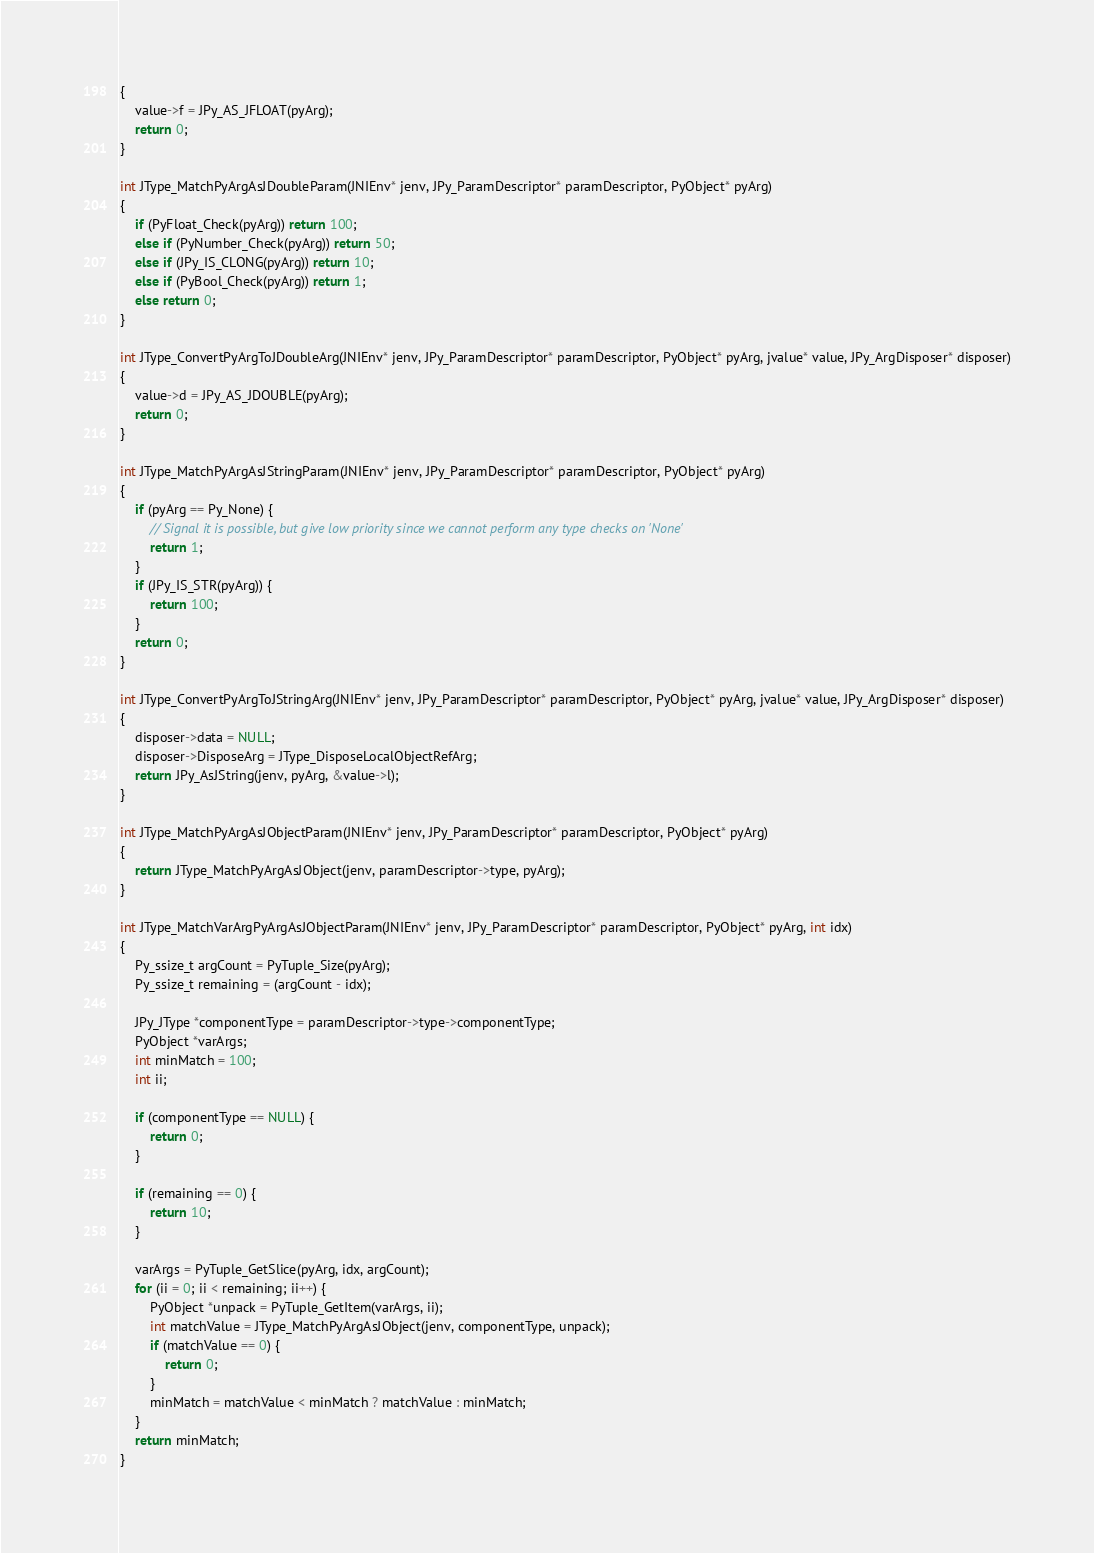Convert code to text. <code><loc_0><loc_0><loc_500><loc_500><_C_>{
    value->f = JPy_AS_JFLOAT(pyArg);
    return 0;
}

int JType_MatchPyArgAsJDoubleParam(JNIEnv* jenv, JPy_ParamDescriptor* paramDescriptor, PyObject* pyArg)
{
    if (PyFloat_Check(pyArg)) return 100;
    else if (PyNumber_Check(pyArg)) return 50;
    else if (JPy_IS_CLONG(pyArg)) return 10;
    else if (PyBool_Check(pyArg)) return 1;
    else return 0;
}

int JType_ConvertPyArgToJDoubleArg(JNIEnv* jenv, JPy_ParamDescriptor* paramDescriptor, PyObject* pyArg, jvalue* value, JPy_ArgDisposer* disposer)
{
    value->d = JPy_AS_JDOUBLE(pyArg);
    return 0;
}

int JType_MatchPyArgAsJStringParam(JNIEnv* jenv, JPy_ParamDescriptor* paramDescriptor, PyObject* pyArg)
{
    if (pyArg == Py_None) {
        // Signal it is possible, but give low priority since we cannot perform any type checks on 'None'
        return 1;
    }
    if (JPy_IS_STR(pyArg)) {
        return 100;
    }
    return 0;
}

int JType_ConvertPyArgToJStringArg(JNIEnv* jenv, JPy_ParamDescriptor* paramDescriptor, PyObject* pyArg, jvalue* value, JPy_ArgDisposer* disposer)
{
    disposer->data = NULL;
    disposer->DisposeArg = JType_DisposeLocalObjectRefArg;
    return JPy_AsJString(jenv, pyArg, &value->l);
}

int JType_MatchPyArgAsJObjectParam(JNIEnv* jenv, JPy_ParamDescriptor* paramDescriptor, PyObject* pyArg)
{
    return JType_MatchPyArgAsJObject(jenv, paramDescriptor->type, pyArg);
}

int JType_MatchVarArgPyArgAsJObjectParam(JNIEnv* jenv, JPy_ParamDescriptor* paramDescriptor, PyObject* pyArg, int idx)
{
    Py_ssize_t argCount = PyTuple_Size(pyArg);
    Py_ssize_t remaining = (argCount - idx);

    JPy_JType *componentType = paramDescriptor->type->componentType;
    PyObject *varArgs;
    int minMatch = 100;
    int ii;

    if (componentType == NULL) {
        return 0;
    }

    if (remaining == 0) {
        return 10;
    }

    varArgs = PyTuple_GetSlice(pyArg, idx, argCount);
    for (ii = 0; ii < remaining; ii++) {
        PyObject *unpack = PyTuple_GetItem(varArgs, ii);
        int matchValue = JType_MatchPyArgAsJObject(jenv, componentType, unpack);
        if (matchValue == 0) {
            return 0;
        }
        minMatch = matchValue < minMatch ? matchValue : minMatch;
    }
    return minMatch;
}
</code> 